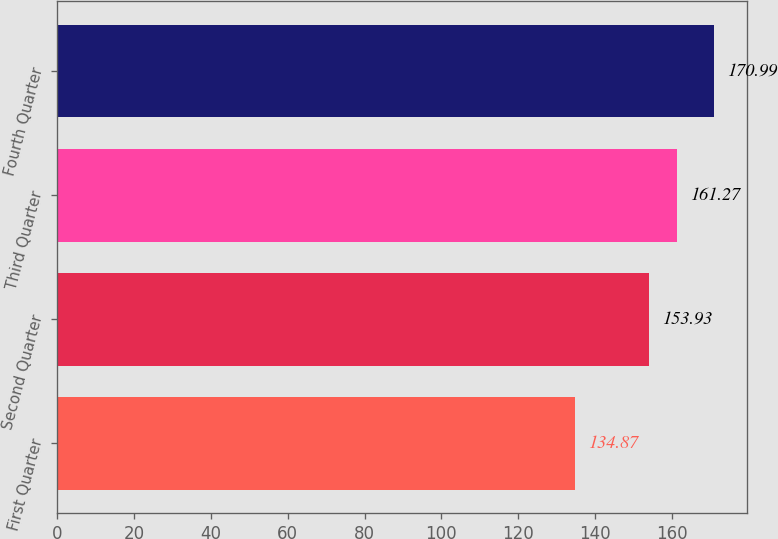<chart> <loc_0><loc_0><loc_500><loc_500><bar_chart><fcel>First Quarter<fcel>Second Quarter<fcel>Third Quarter<fcel>Fourth Quarter<nl><fcel>134.87<fcel>153.93<fcel>161.27<fcel>170.99<nl></chart> 